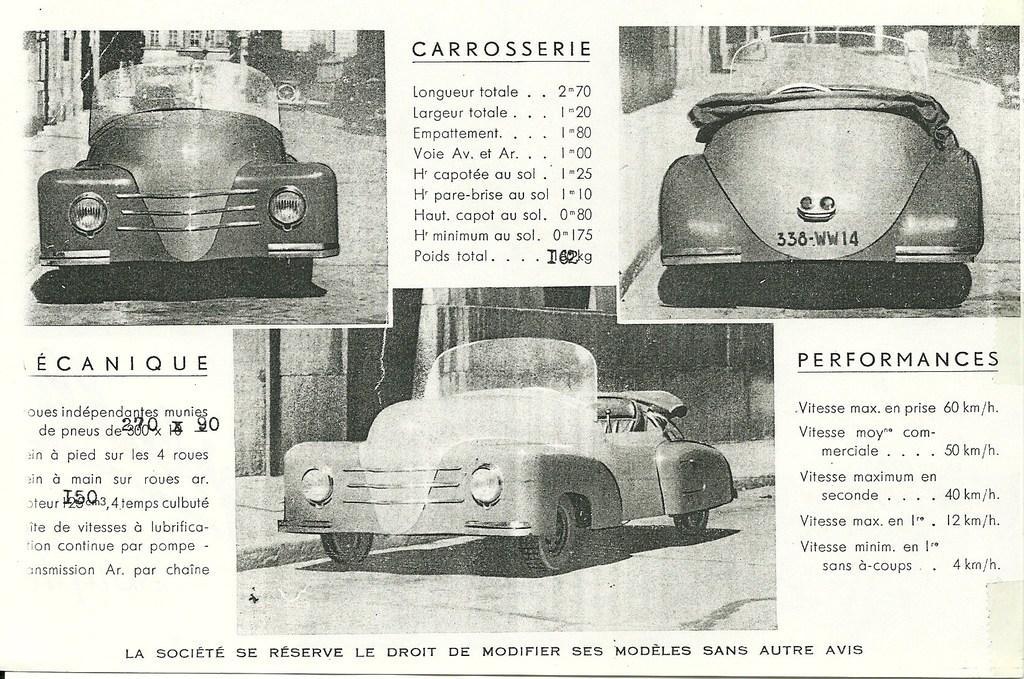Please provide a concise description of this image. In this picture we can see a paper, here we can see three cars and some text. 